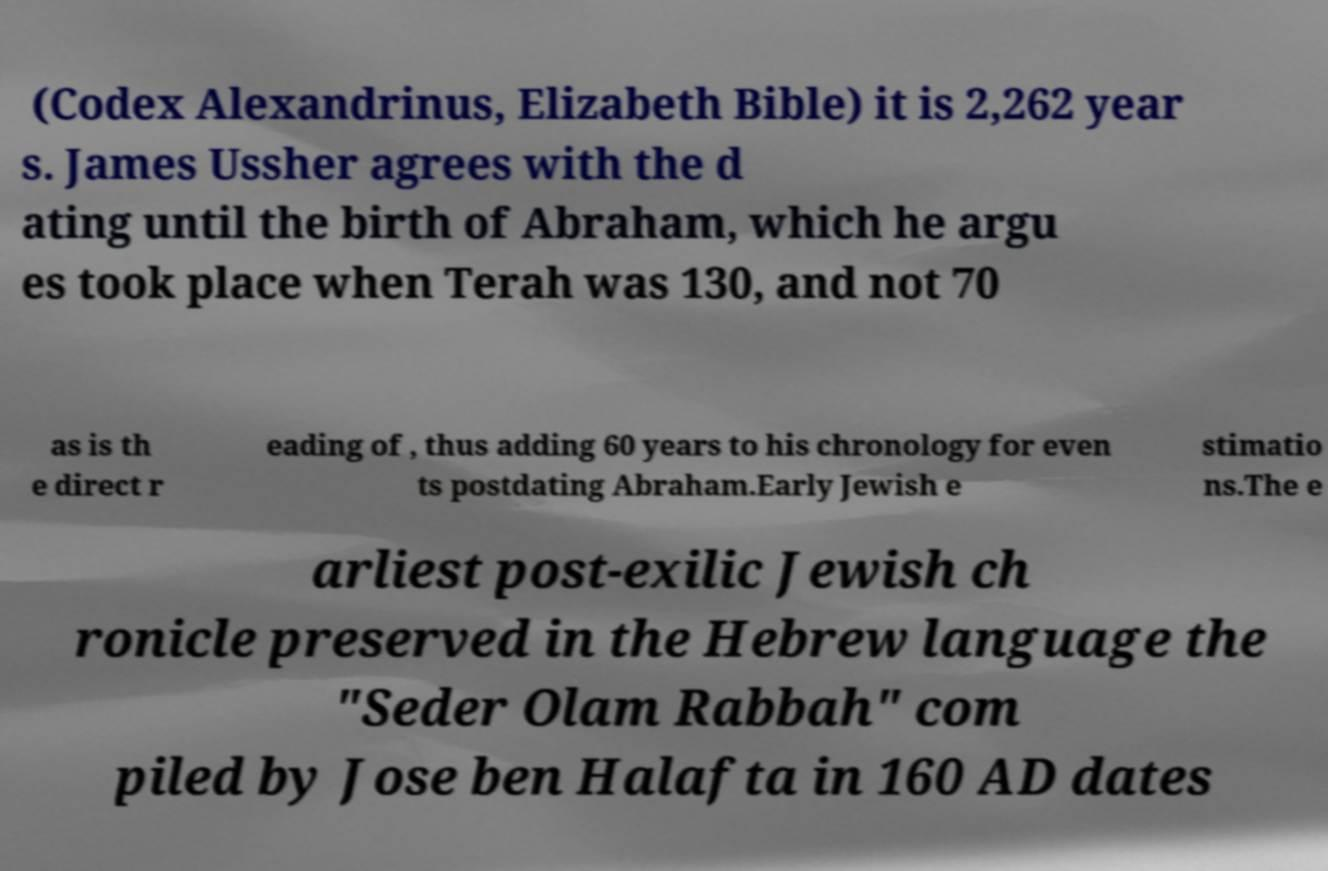Could you extract and type out the text from this image? (Codex Alexandrinus, Elizabeth Bible) it is 2,262 year s. James Ussher agrees with the d ating until the birth of Abraham, which he argu es took place when Terah was 130, and not 70 as is th e direct r eading of , thus adding 60 years to his chronology for even ts postdating Abraham.Early Jewish e stimatio ns.The e arliest post-exilic Jewish ch ronicle preserved in the Hebrew language the "Seder Olam Rabbah" com piled by Jose ben Halafta in 160 AD dates 